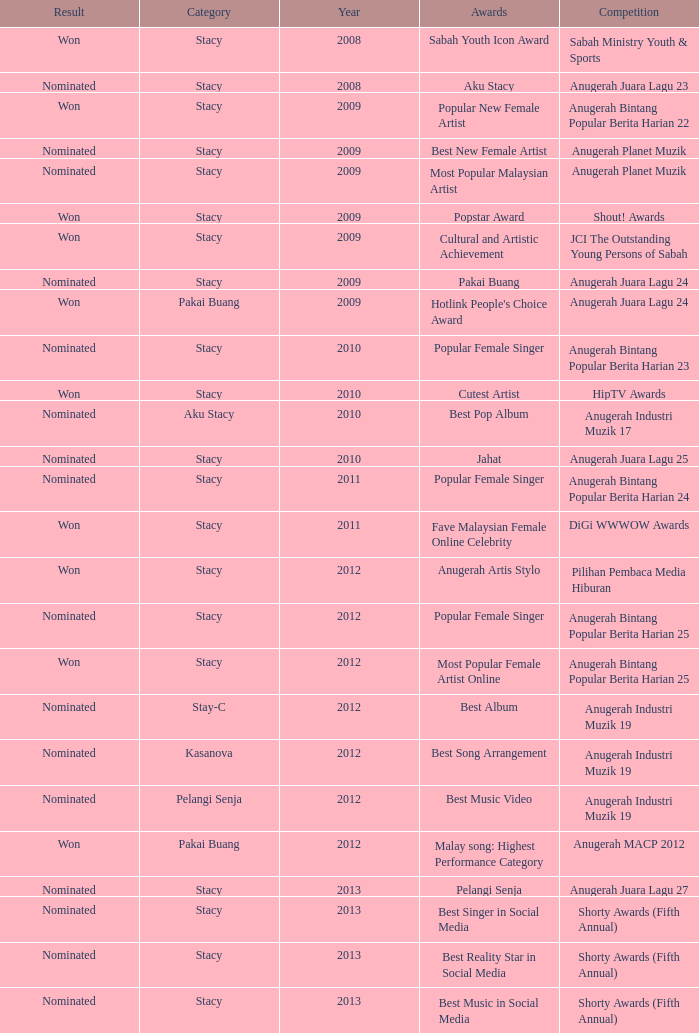What was the year that had Anugerah Bintang Popular Berita Harian 23 as competition? 1.0. 